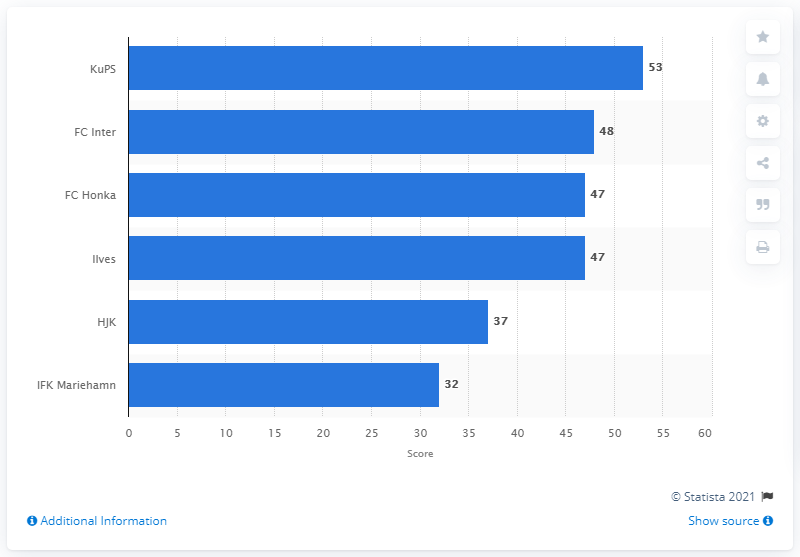Indicate a few pertinent items in this graphic. KuPS won the Finnish Football League in 2019. The FC Inter professional football club, based in Turku, is named after the Italian football club Inter Milan. 